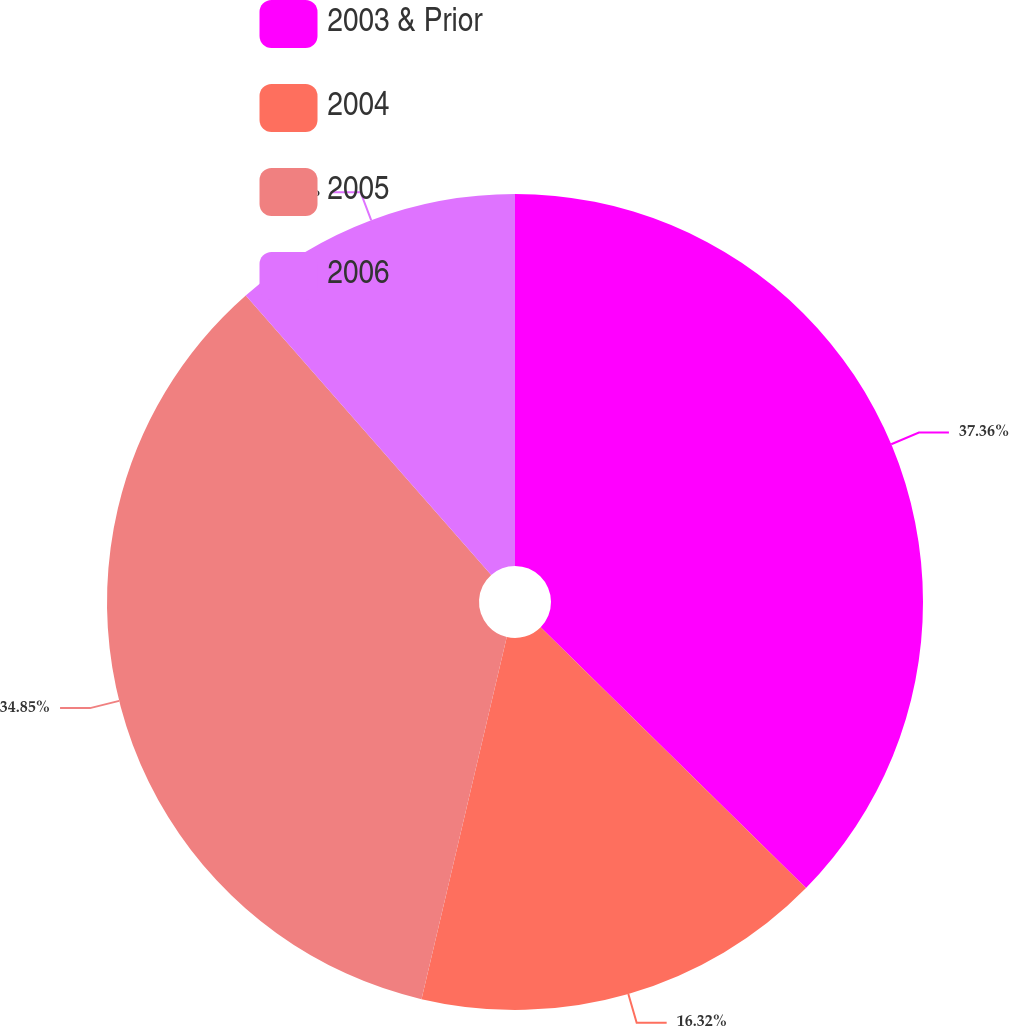Convert chart to OTSL. <chart><loc_0><loc_0><loc_500><loc_500><pie_chart><fcel>2003 & Prior<fcel>2004<fcel>2005<fcel>2006<nl><fcel>37.36%<fcel>16.32%<fcel>34.85%<fcel>11.47%<nl></chart> 